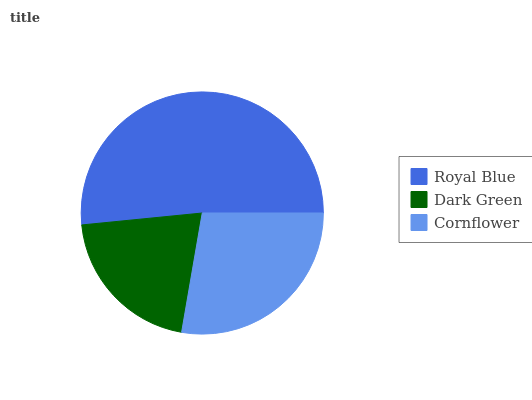Is Dark Green the minimum?
Answer yes or no. Yes. Is Royal Blue the maximum?
Answer yes or no. Yes. Is Cornflower the minimum?
Answer yes or no. No. Is Cornflower the maximum?
Answer yes or no. No. Is Cornflower greater than Dark Green?
Answer yes or no. Yes. Is Dark Green less than Cornflower?
Answer yes or no. Yes. Is Dark Green greater than Cornflower?
Answer yes or no. No. Is Cornflower less than Dark Green?
Answer yes or no. No. Is Cornflower the high median?
Answer yes or no. Yes. Is Cornflower the low median?
Answer yes or no. Yes. Is Dark Green the high median?
Answer yes or no. No. Is Dark Green the low median?
Answer yes or no. No. 